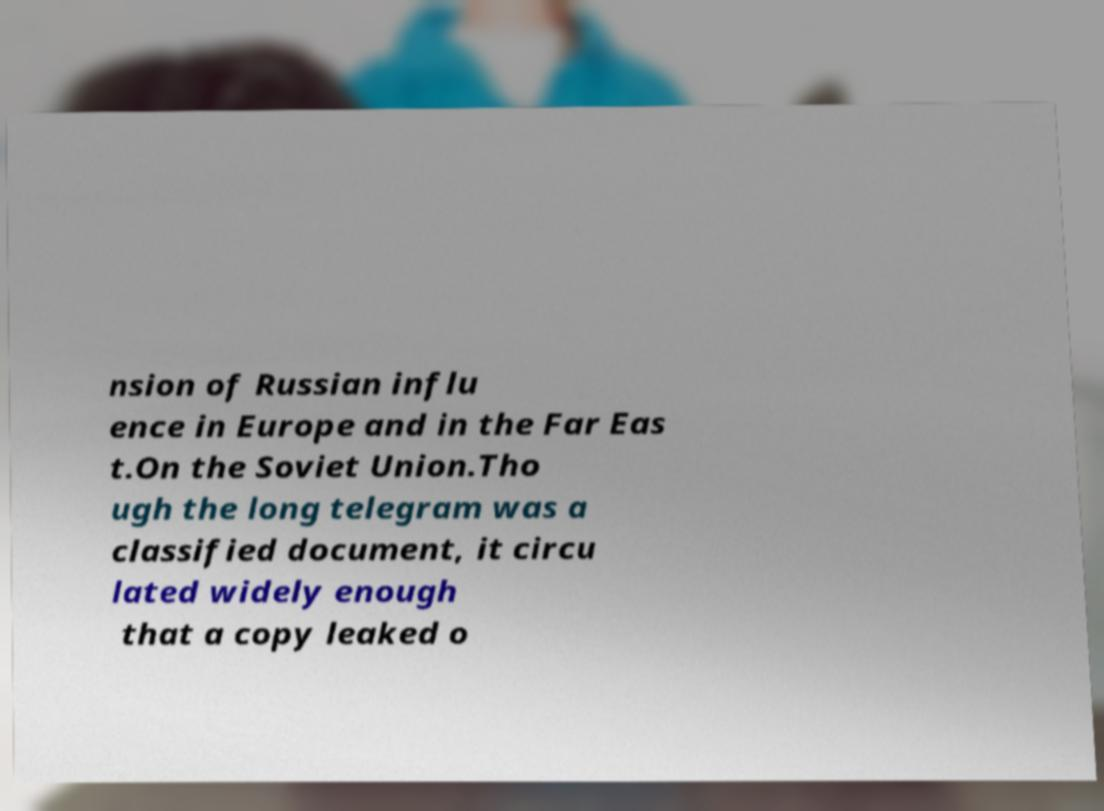Please identify and transcribe the text found in this image. nsion of Russian influ ence in Europe and in the Far Eas t.On the Soviet Union.Tho ugh the long telegram was a classified document, it circu lated widely enough that a copy leaked o 